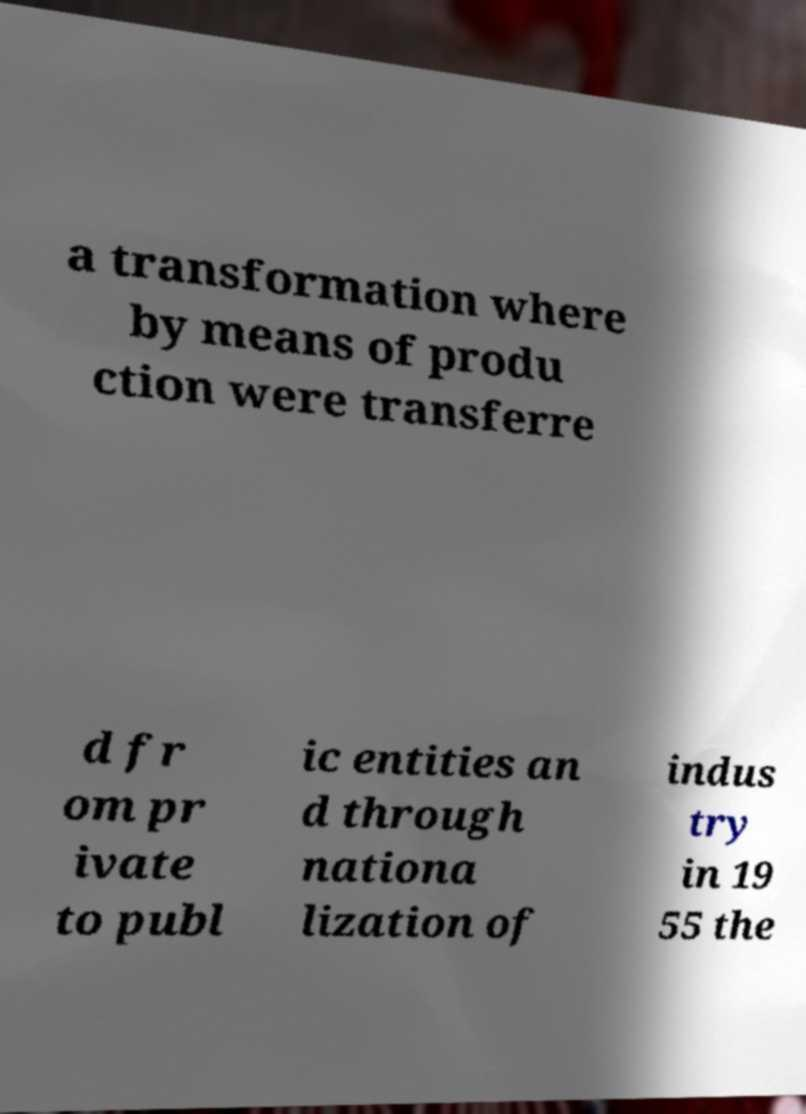Could you assist in decoding the text presented in this image and type it out clearly? a transformation where by means of produ ction were transferre d fr om pr ivate to publ ic entities an d through nationa lization of indus try in 19 55 the 